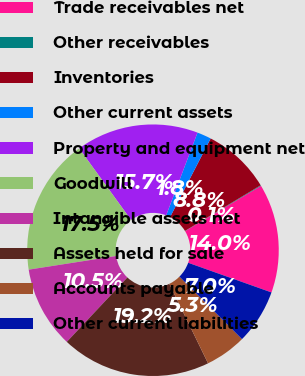Convert chart. <chart><loc_0><loc_0><loc_500><loc_500><pie_chart><fcel>Trade receivables net<fcel>Other receivables<fcel>Inventories<fcel>Other current assets<fcel>Property and equipment net<fcel>Goodwill<fcel>Intangible assets net<fcel>Assets held for sale<fcel>Accounts payable<fcel>Other current liabilities<nl><fcel>14.0%<fcel>0.08%<fcel>8.78%<fcel>1.82%<fcel>15.74%<fcel>17.48%<fcel>10.52%<fcel>19.22%<fcel>5.3%<fcel>7.04%<nl></chart> 